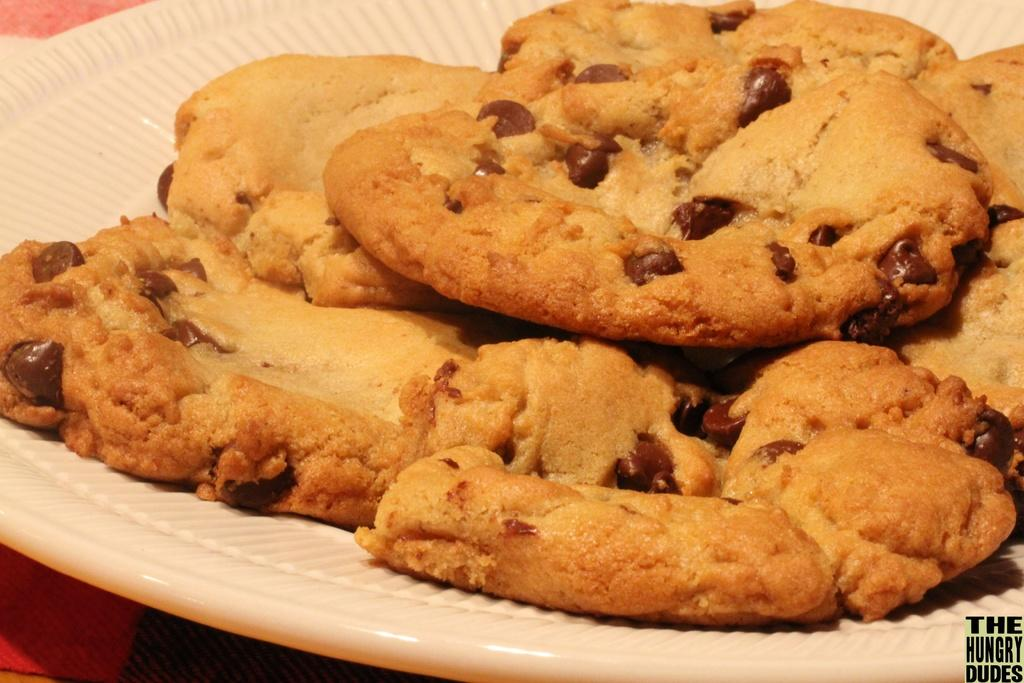What is on the plate that is visible in the image? The plate contains cookies. What color is the plate in the image? The plate is white. Can you describe any other objects or features in the image? There is an unidentified red object in the left bottom of the image. What is the name of the group that is performing in the image? There is no group performing in the image; it features a plate of cookies and an unidentified red object. How many grapes are visible on the plate in the image? There are no grapes present in the image; it contains cookies on a white plate. 